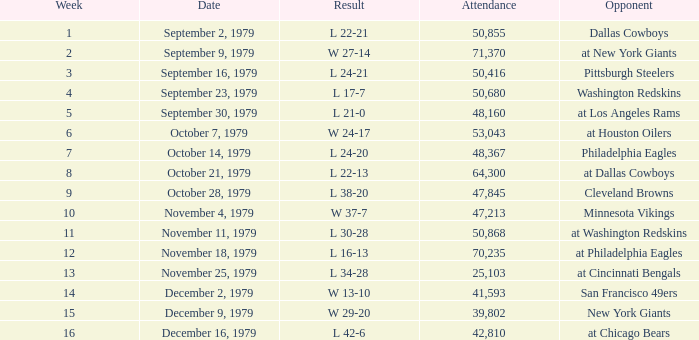What is the highest week when attendance is greater than 64,300 with a result of w 27-14? 2.0. 